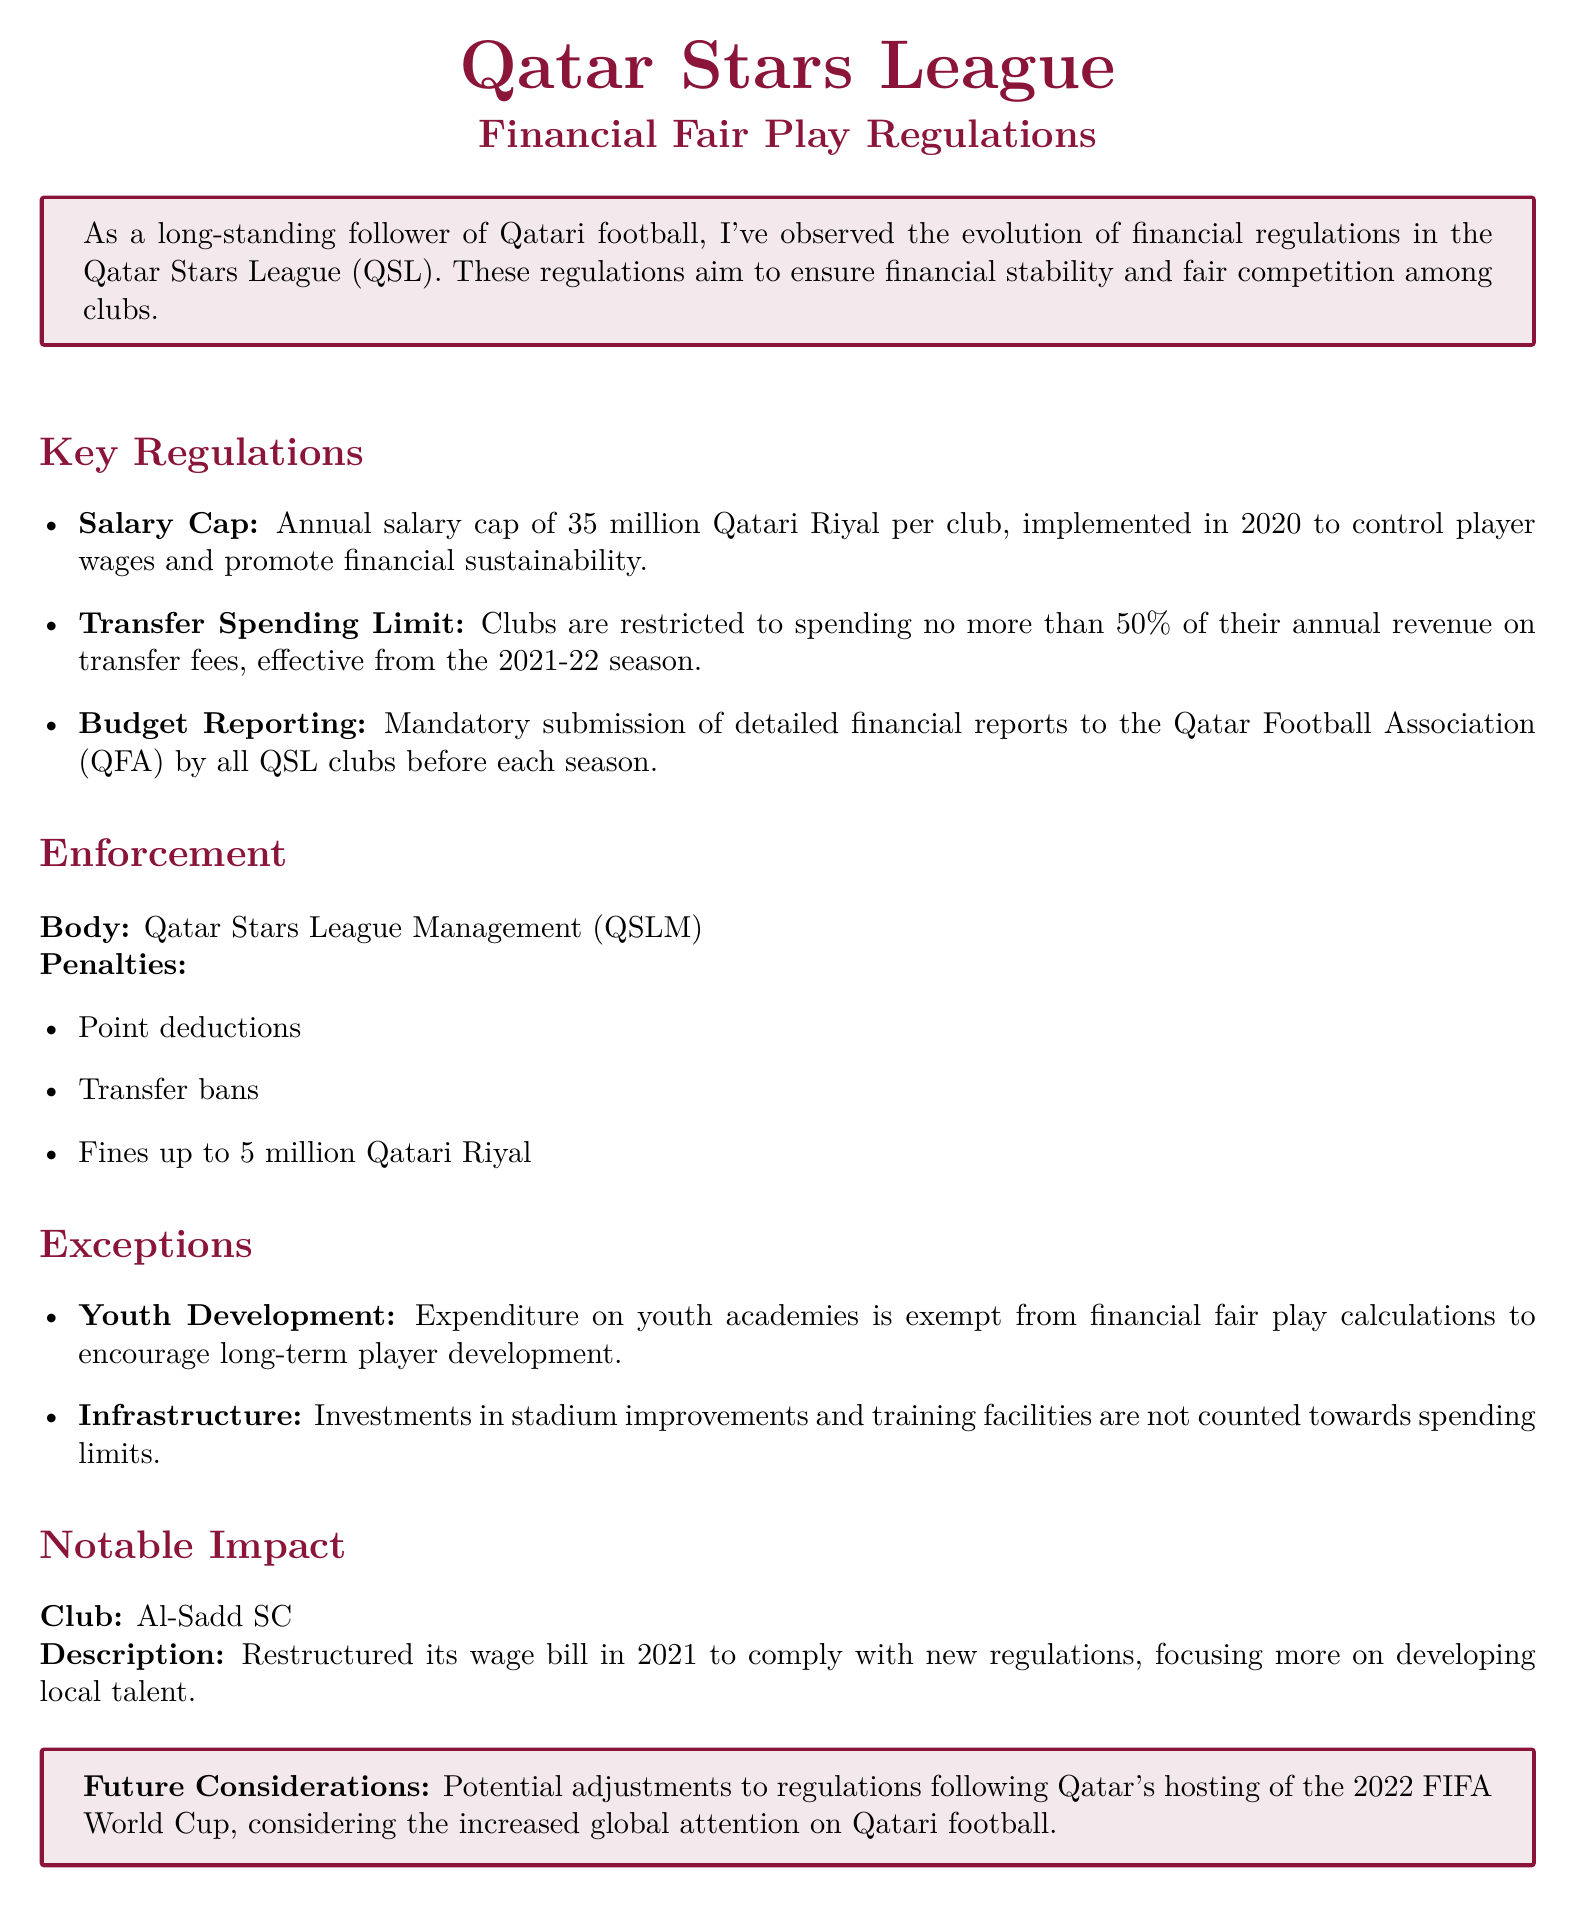What is the annual salary cap per club? The document states that the annual salary cap per club is established to promote financial sustainability.
Answer: 35 million Qatari Riyal What percentage of annual revenue can clubs spend on transfer fees? According to the regulations, clubs have clear restrictions on transfer spending to ensure financial discipline.
Answer: 50% Which organization is responsible for enforcing the financial fair play regulations? The document specifies the body responsible for enforcing these financial regulations in the league.
Answer: Qatar Stars League Management (QSLM) What are the penalties for violating the financial fair play regulations? The document lists multiple penalties for clubs that do not adhere to the financial regulations.
Answer: Point deductions, transfer bans, fines up to 5 million Qatari Riyal What type of spending is exempt from financial fair play calculations? The document identifies specific areas of investment that do not count towards spending limits, aiming to support certain initiatives.
Answer: Youth academies Which club restructured its wage bill to comply with new regulations? The document highlights a notable example of compliance under the new financial fair play regulations within the league.
Answer: Al-Sadd SC What major event may influence future considerations of the regulations? The document notes an important upcoming event that could lead to adjustments in the existing financial regulations.
Answer: 2022 FIFA World Cup What is the primary aim of the financial fair play regulations? The document elaborates on the underlying goal of these regulations within the Qatar Stars League context.
Answer: Financial stability and fair competition 